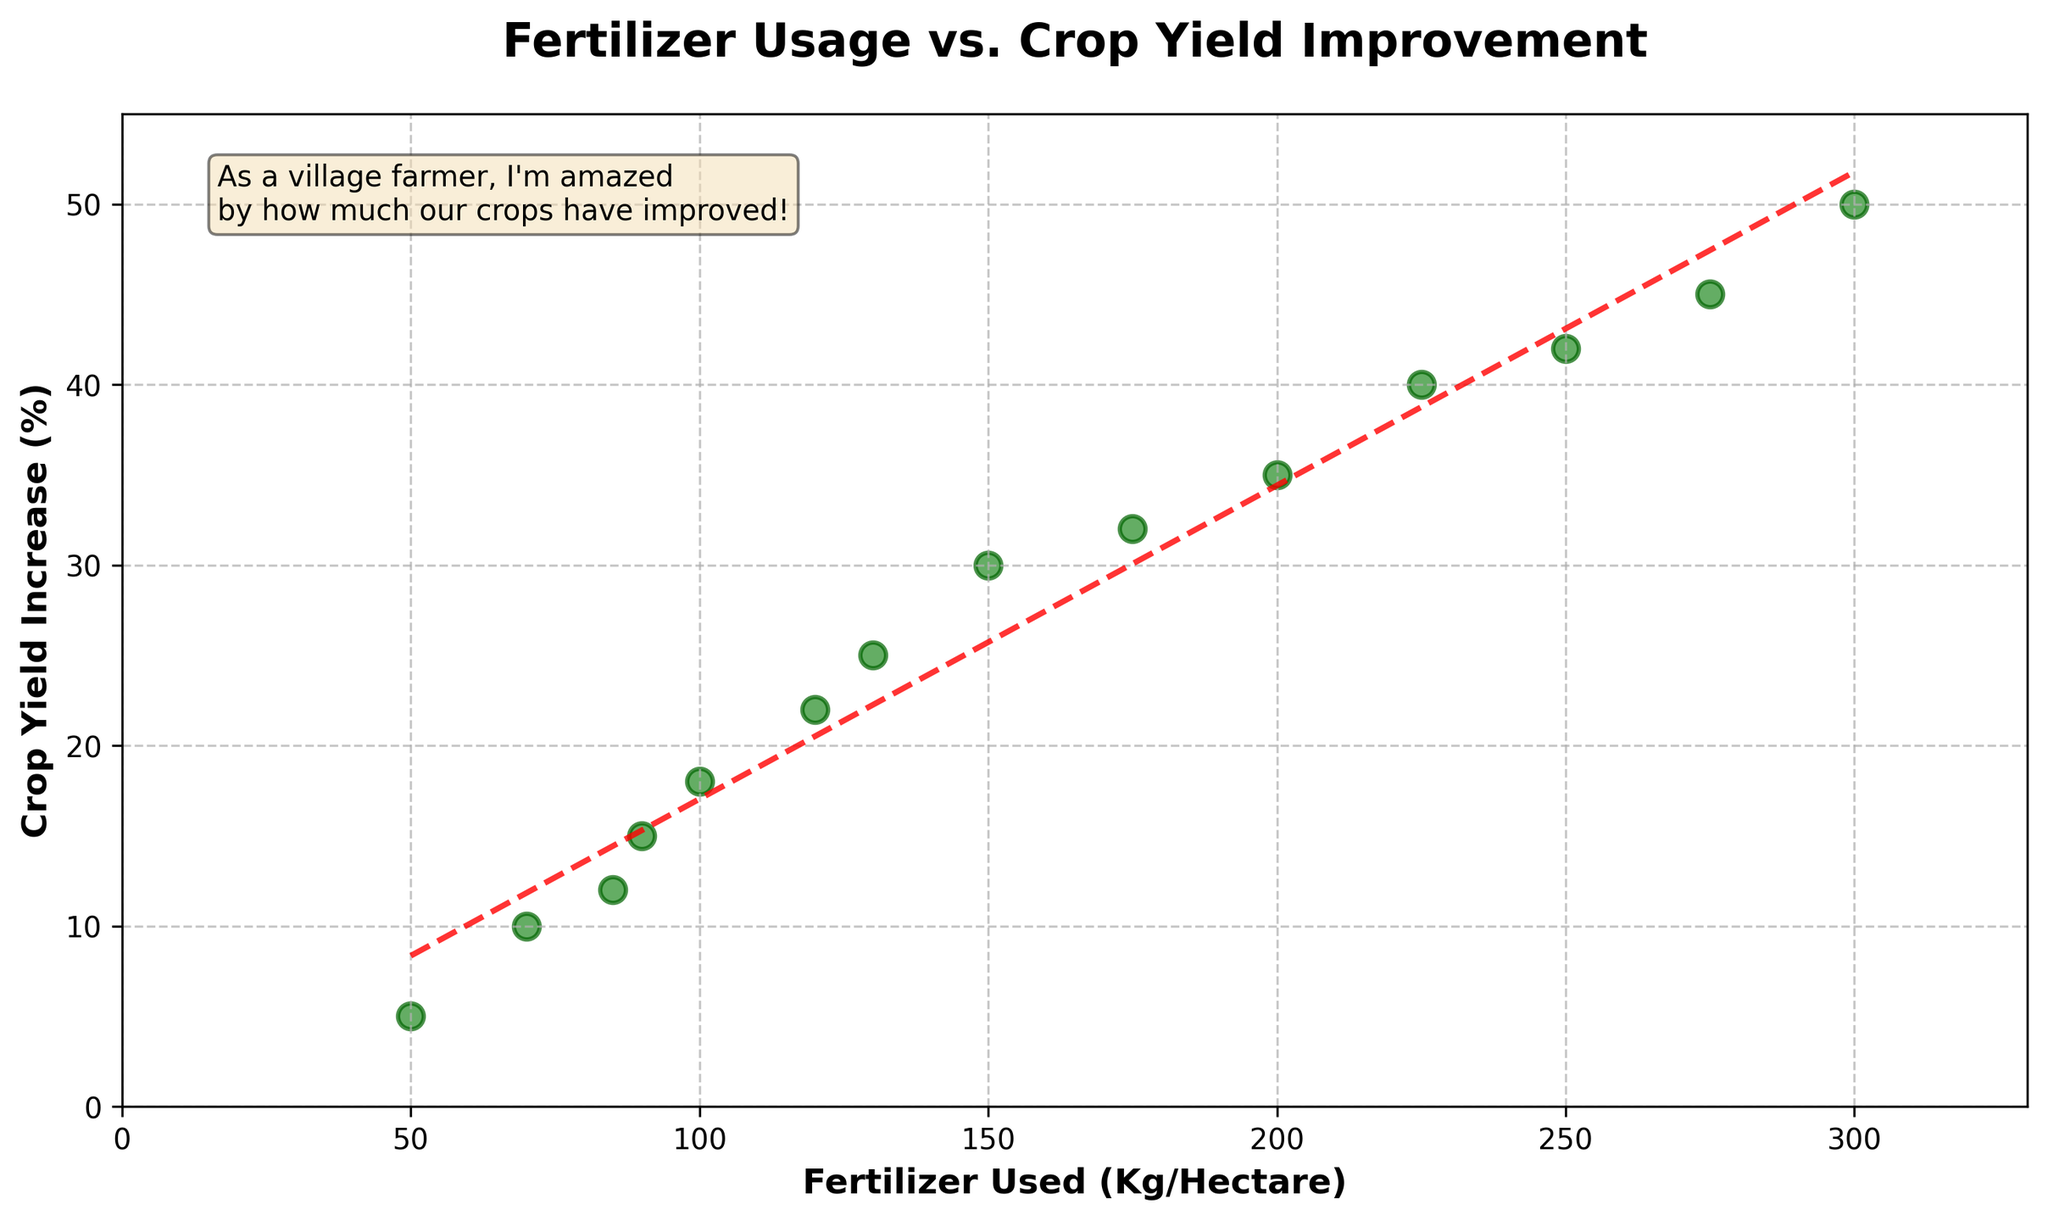How many data points are there in the figure? There are markers representing each data point in the scatter plot. Counting these markers, there are 14 data points in the figure.
Answer: 14 What are the labels of the x-axis and y-axis? Looking at the figure, the x-axis is labeled "Fertilizer Used (Kg/Hectare)" and the y-axis is labeled "Crop Yield Increase (%)".
Answer: Fertilizer Used (Kg/Hectare), Crop Yield Increase (%) What is the maximum value on the y-axis for crop yield increase percentage? Observing the y-axis, the maximum value is labeled 50, which lies at the top end of the axis.
Answer: 50 Is there an overall trend in the relationship between fertilizer usage and crop yield improvement? The trend line added to the scatter plot shows a positive slope, indicating an overall positive relationship where an increase in fertilizer usage generally leads to an increase in crop yield improvement.
Answer: Yes, positive What is the fertilizer usage when the crop yield increase percentage is 30%? On the scatter plot, find the data point where the crop yield increase percentage is 30%. The corresponding x-value for fertilizer usage is 150 Kg/Hectare.
Answer: 150 Kg/Hectare Which data point shows the highest crop yield increase and what is its fertilizer usage? Ascertain the highest point on the y-axis which represents the highest crop yield increase percentage. This data point is at 50% crop yield increase and corresponds to 300 Kg/Hectare fertilizer usage.
Answer: 50%, 300 Kg/Hectare Between 100 Kg/Hectare and 200 Kg/Hectare fertilizer usage, how much does the crop yield increase percentage change? Locate the data points at 100 Kg/Hectare (18%) and 200 Kg/Hectare (35%). The change in crop yield increase is 35% - 18% which totals 17%.
Answer: 17% Does increasing fertilizer usage from 50 Kg/Hectare to 150 Kg/Hectare show a linear increase in crop yield improvement? Comparing the data points at 50 Kg/Hectare (5%) and 150 Kg/Hectare (30%), the increase in crop yield is not perfectly linear but generally shows a steady increase. This can be inferred from the trend line which overall shows a positive growth.
Answer: No, not perfectly linear How does the trend line compare to the individual data points? The trend line acts as an approximate average of the data points. Individual data points closely follow the trend line but may not always align perfectly. This shows that while the trend is generally positive, actual results have some variability.
Answer: Close but variable What is the percentage increase in crop yield from 250 Kg/Hectare to 300 Kg/Hectare fertilizer usage? Identify the crop yield percentages at 250 Kg/Hectare (42%) and 300 Kg/Hectare (50%). The percentage increase in crop yield is 50% - 42% which equals 8%.
Answer: 8% 